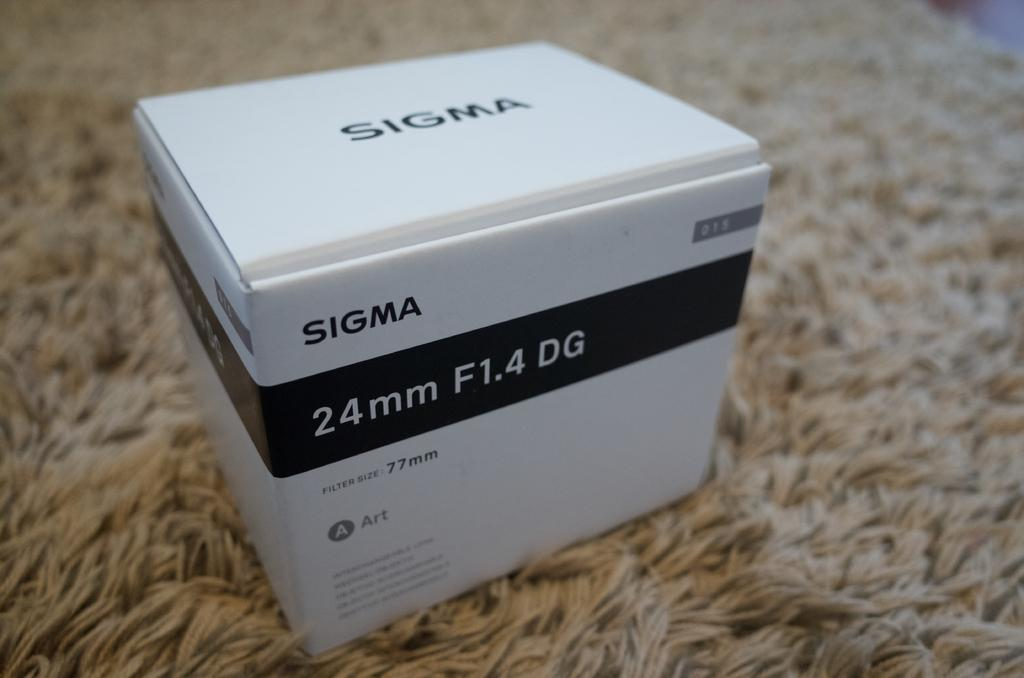Provide a one-sentence caption for the provided image. A white Sigma package with the label 24mm F1.4 DG on the box. 